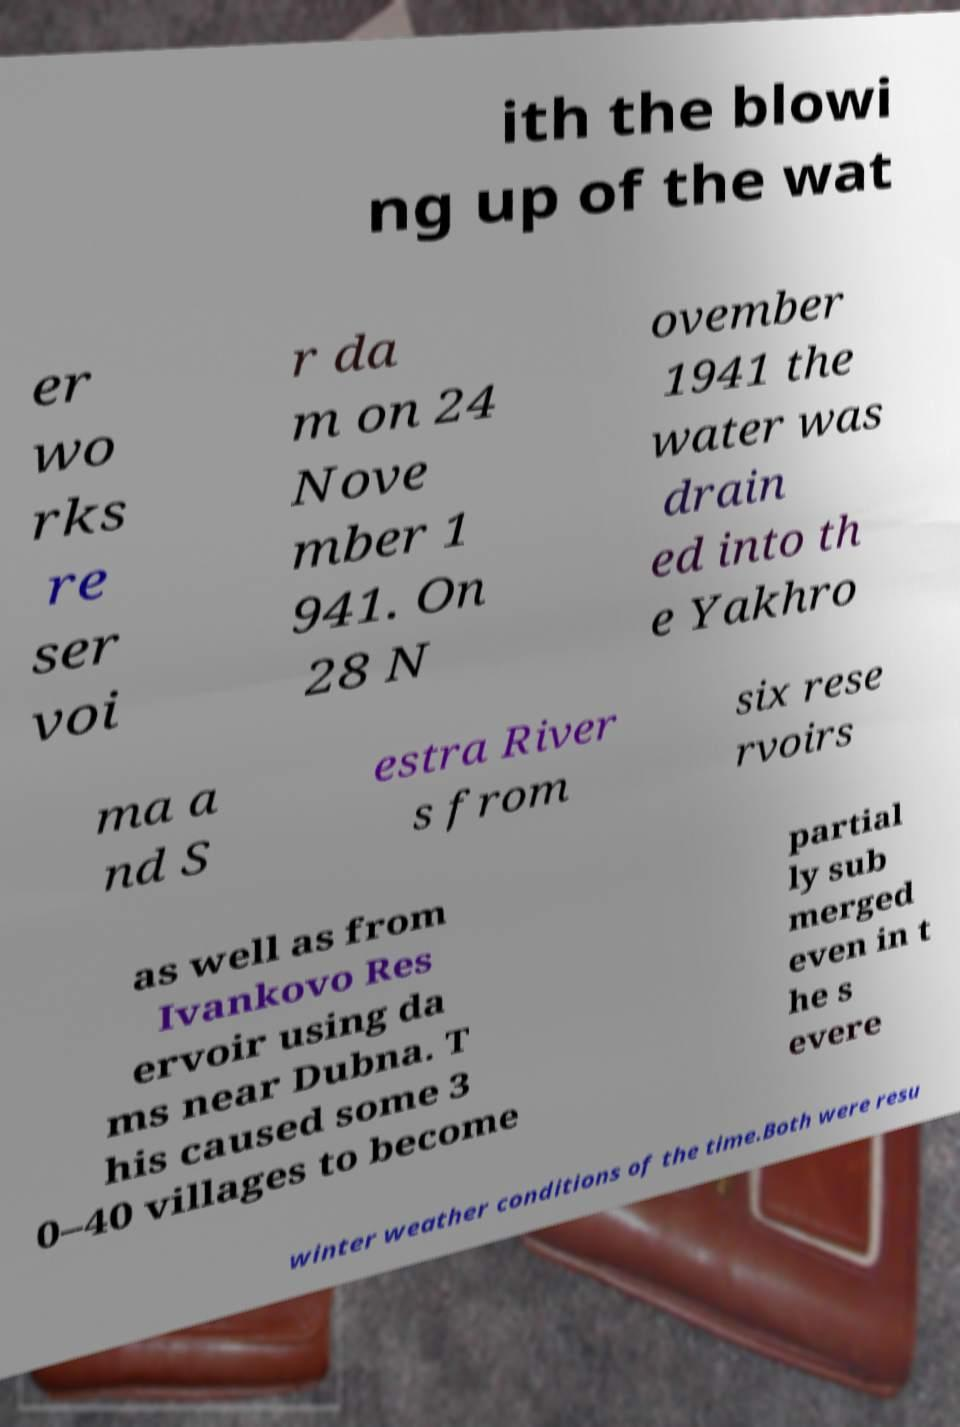Please read and relay the text visible in this image. What does it say? ith the blowi ng up of the wat er wo rks re ser voi r da m on 24 Nove mber 1 941. On 28 N ovember 1941 the water was drain ed into th e Yakhro ma a nd S estra River s from six rese rvoirs as well as from Ivankovo Res ervoir using da ms near Dubna. T his caused some 3 0–40 villages to become partial ly sub merged even in t he s evere winter weather conditions of the time.Both were resu 